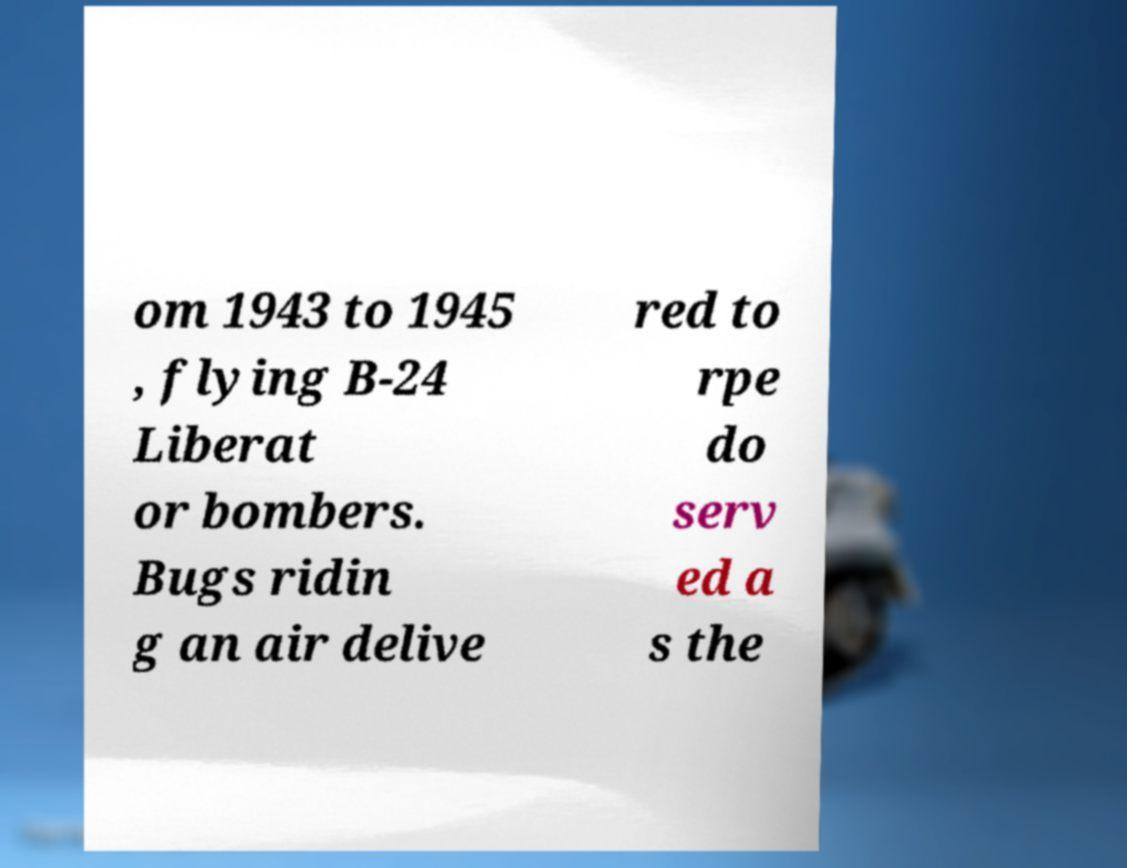Could you extract and type out the text from this image? om 1943 to 1945 , flying B-24 Liberat or bombers. Bugs ridin g an air delive red to rpe do serv ed a s the 